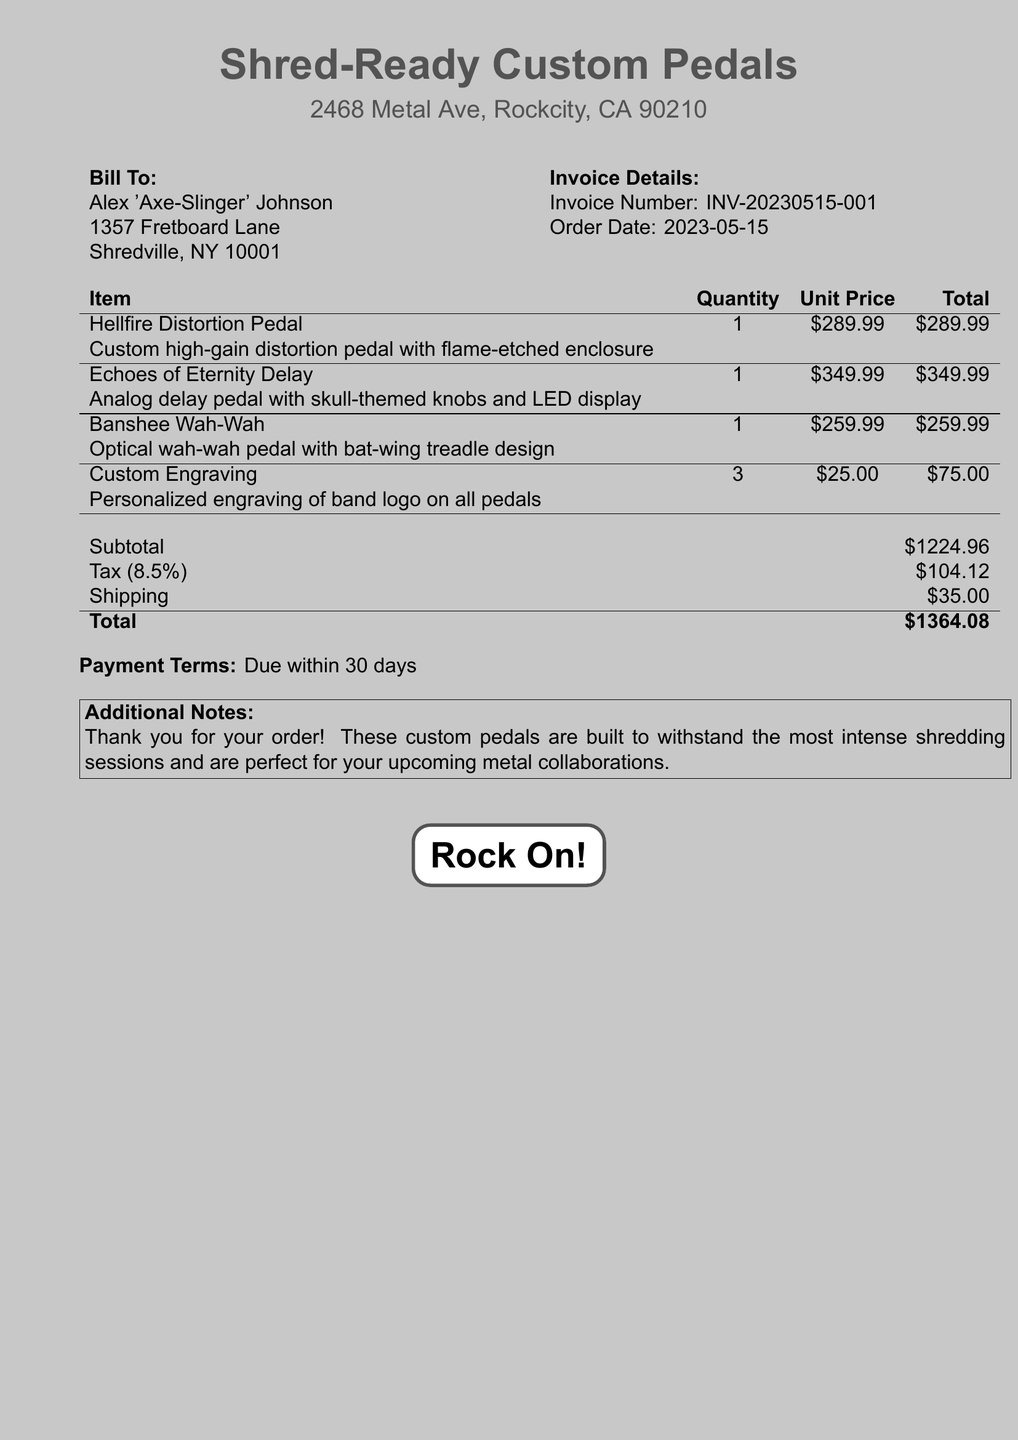What is the invoice number? The invoice number is specified in the document under "Invoice Details."
Answer: INV-20230515-001 Who is the bill addressed to? The name of the recipient is listed under "Bill To."
Answer: Alex 'Axe-Slinger' Johnson What is the unit price of the Hellfire Distortion Pedal? The unit price is located in the itemized list of the document next to the corresponding item.
Answer: $289.99 How many custom engravings were ordered? The quantity of custom engravings is provided in the section detailing the items.
Answer: 3 What is the total after tax and shipping? The total amount is calculated by adding the subtotal, tax, and shipping in the final section.
Answer: $1364.08 What theme is used for the knobs on the Echoes of Eternity Delay? The theme for the knobs is mentioned in the description of the Echoes of Eternity Delay pedal.
Answer: Skull-themed What is the subtotal amount before tax and shipping? The subtotal is indicated as the total of the itemized costs before additional charges.
Answer: $1224.96 What is the shipping cost listed in the bill? The shipping cost is detailed in the financial summary at the end of the document.
Answer: $35.00 What is the due date for payment? The payment terms at the bottom specify the timeline for payment.
Answer: Within 30 days What does the custom engraving include? The document details the type of custom engraving provided for the pedals in the item description.
Answer: Personalized engraving of band logo 